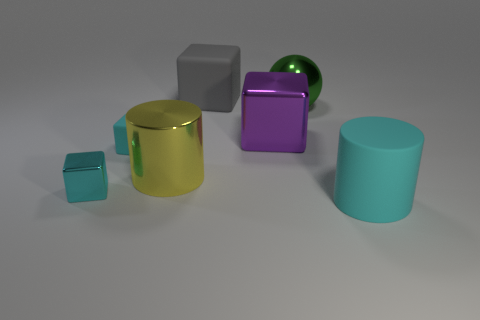What number of balls are either big purple things or big gray rubber things? I can see there are no balls that match the description of being either big and purple or big and gray rubber in the image. The only ball present is green, and there are various other objects of different colors and materials. 